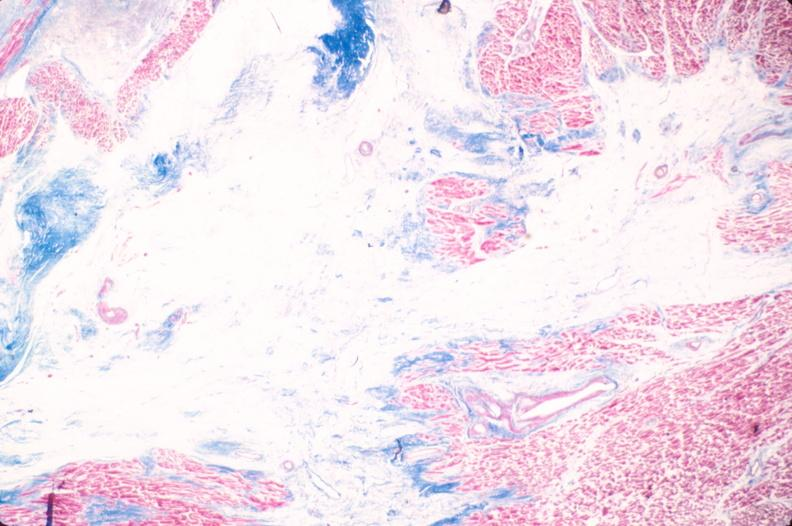what does this image show?
Answer the question using a single word or phrase. Heart 